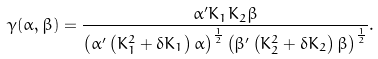<formula> <loc_0><loc_0><loc_500><loc_500>\gamma ( \alpha , \beta ) = \frac { \alpha ^ { \prime } K _ { 1 } K _ { 2 } \beta } { \left ( \alpha ^ { \prime } \left ( K _ { 1 } ^ { 2 } + \delta K _ { 1 } \right ) \alpha \right ) ^ { \frac { 1 } { 2 } } \left ( \beta ^ { \prime } \left ( K _ { 2 } ^ { 2 } + \delta K _ { 2 } \right ) \beta \right ) ^ { \frac { 1 } { 2 } } } .</formula> 